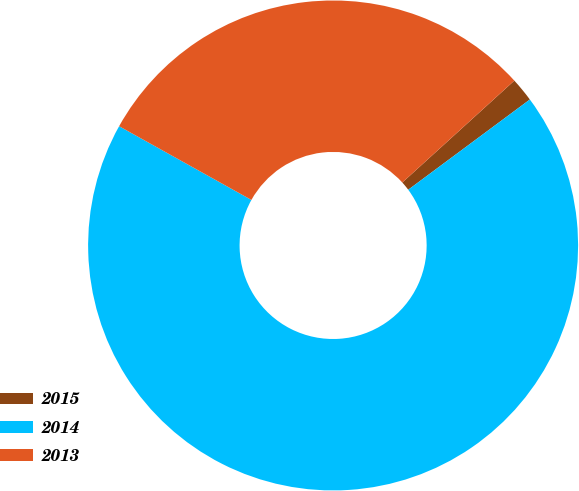<chart> <loc_0><loc_0><loc_500><loc_500><pie_chart><fcel>2015<fcel>2014<fcel>2013<nl><fcel>1.59%<fcel>68.25%<fcel>30.16%<nl></chart> 